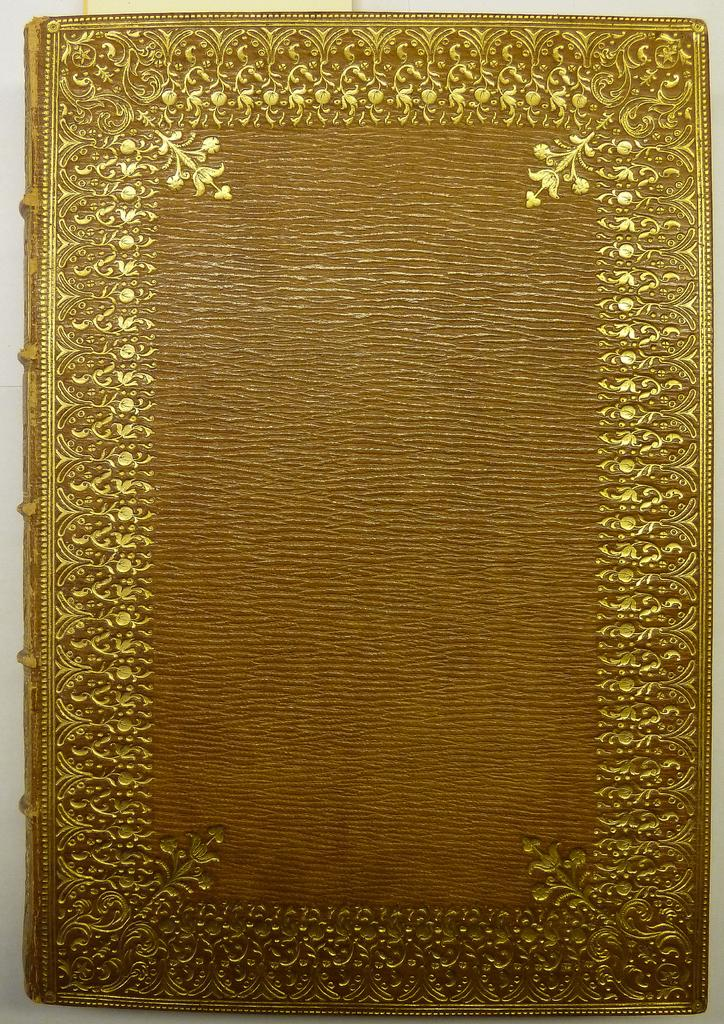What object can be seen in the image? There is a book in the image. What colors are present on the book? The book has orange and gold colors. What type of knife is used to cut the sandwich in the image? There is no sandwich or knife present in the image; it only features a book with orange and gold colors. 